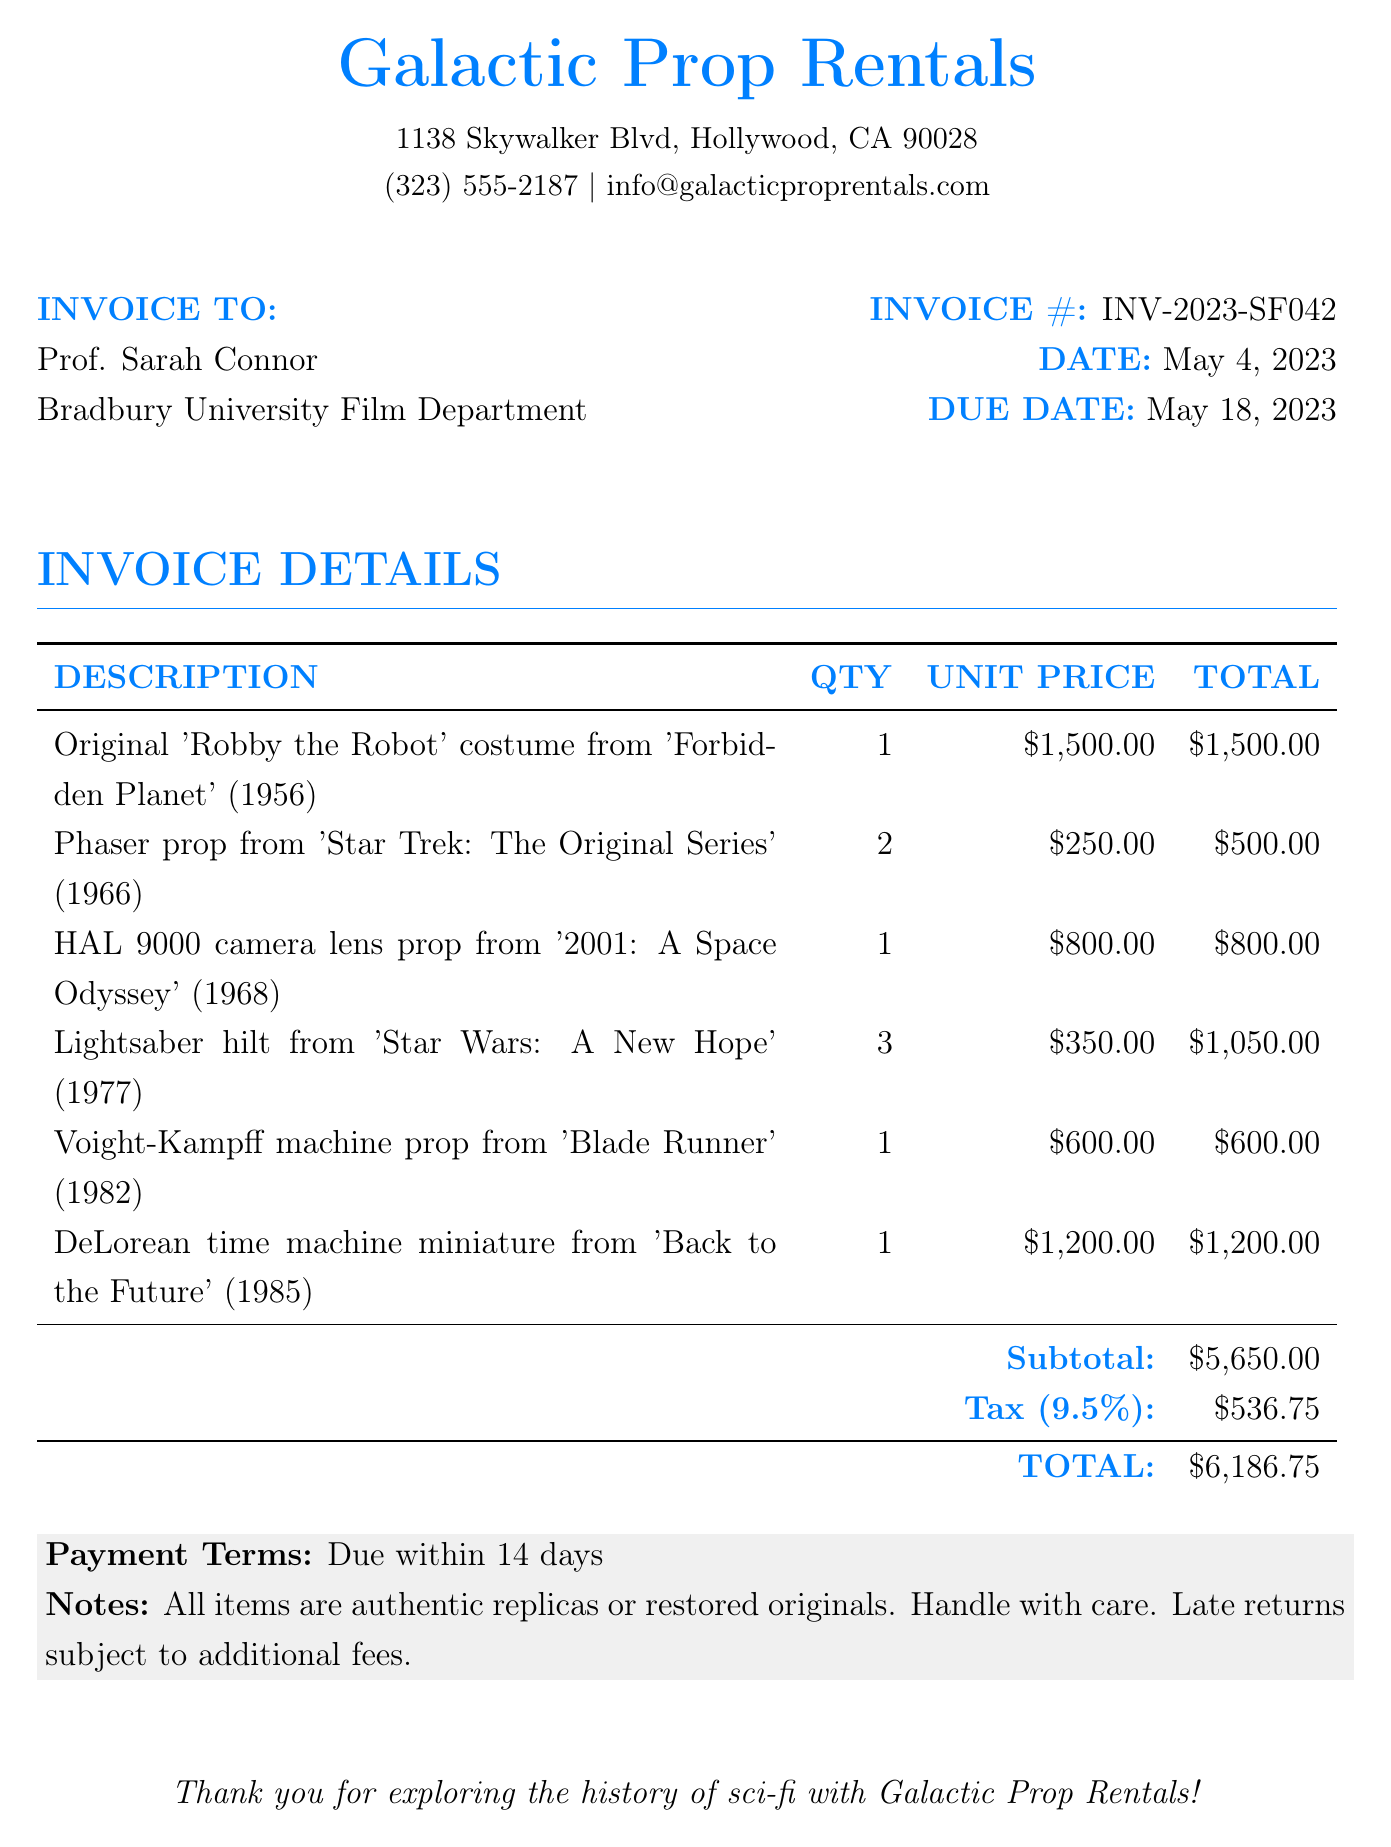What is the invoice number? The invoice number is a unique identifier for the transaction detailed in the document, which is INV-2023-SF042.
Answer: INV-2023-SF042 Who is the invoice addressed to? The invoice lists Prof. Sarah Connor as the recipient, indicating who is responsible for the payment.
Answer: Prof. Sarah Connor What is the subtotal amount? The subtotal amount is the total before tax is added, which is indicated as $5,650.00.
Answer: $5,650.00 How many Lightsaber hilts were rented? The document specifies that three Lightsaber hilts were rented, which contributes to the total cost.
Answer: 3 What is the tax rate applied? The tax is specified as 9.5%, indicating the percentage applied to the subtotal for calculation of tax.
Answer: 9.5% When is the payment due? The due date of the payment is specified in the document as May 18, 2023.
Answer: May 18, 2023 What is the total amount due? The total amount due combines the subtotal and the tax, which is clearly represented at the bottom of the invoice as $6,186.75.
Answer: $6,186.75 How many different props are listed in the invoice? The document lists six distinct types of props and costumes, which can be counted from the details of the invoice.
Answer: 6 What is the payment term mentioned? The payment terms are specified in the invoice as due within 14 days of the date issued.
Answer: Due within 14 days 